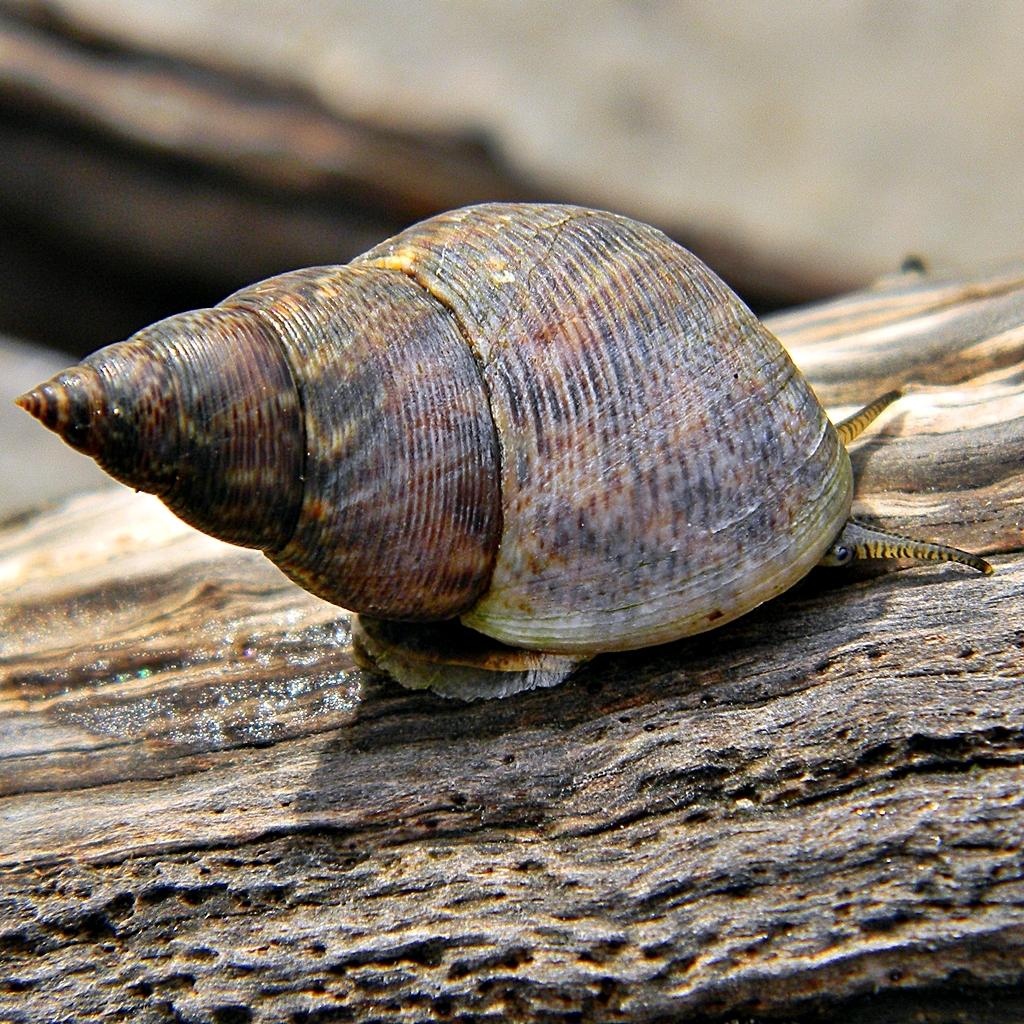What is the main subject of the image? The main subject of the image is a snail. What is the snail resting on in the image? The snail is on a wooden object. Can you describe the background of the image? The background of the image is blurred. What type of treatment is the snail undergoing in the image? There is no indication in the image that the snail is undergoing any treatment. How does the snail aid in the digestion process in the image? The image does not show the snail aiding in any digestion process. 